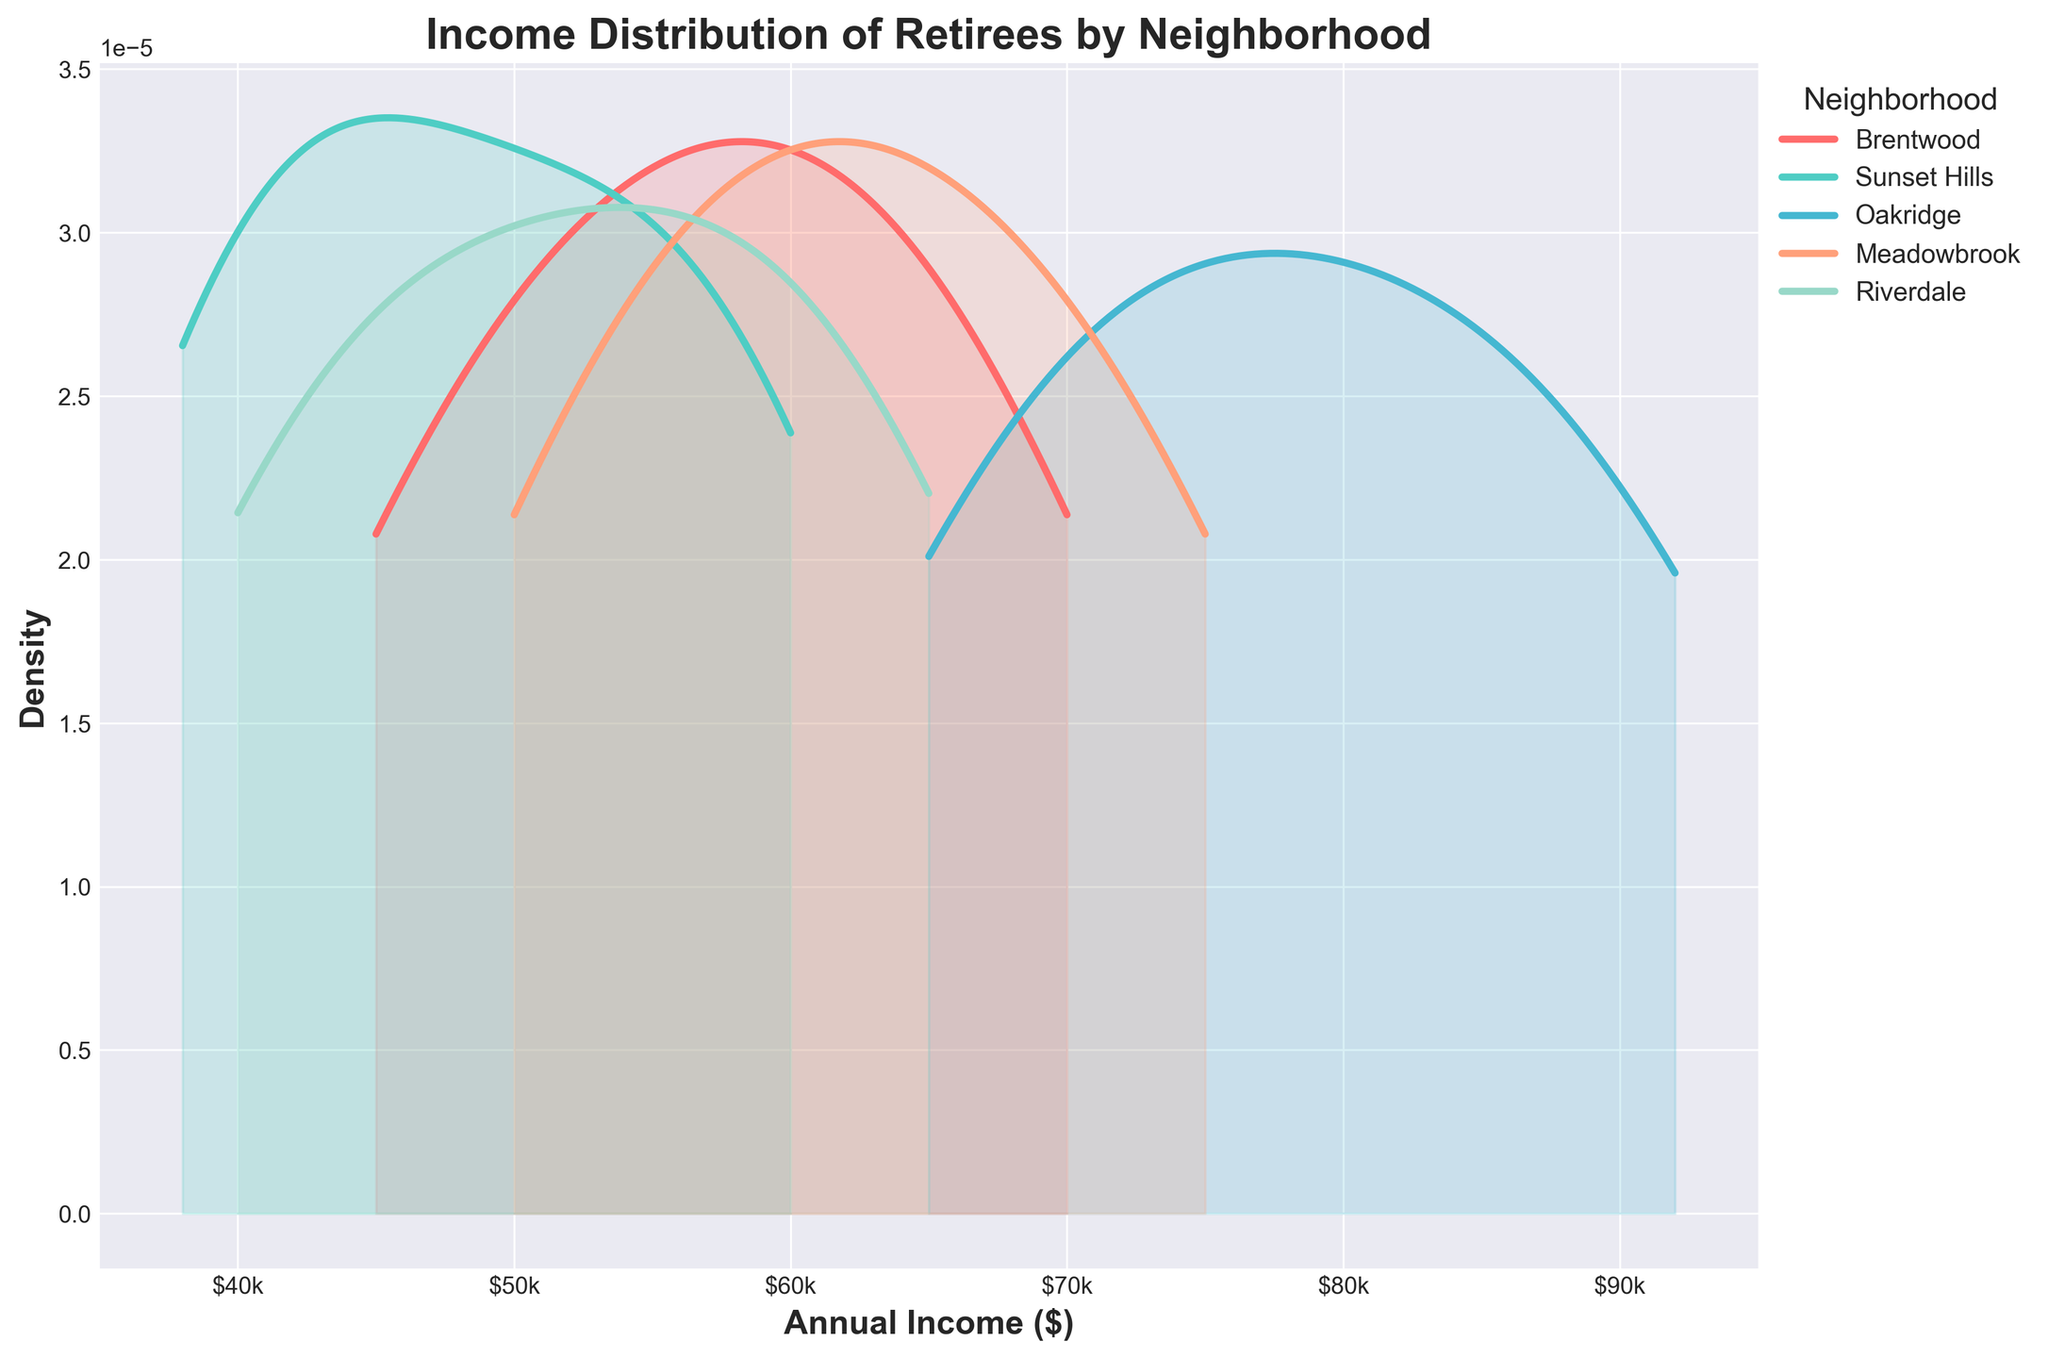What is the title of the plot? The title of the plot is usually displayed at the top. In this case, it clearly states the subject of the plot.
Answer: Income Distribution of Retirees by Neighborhood What does the x-axis represent? The x-axis label can be seen at the bottom of the plot, indicating what is being measured. Here it represents the annual income in dollars.
Answer: Annual Income Which neighborhood shows the highest density peak? By observing the density peaks of the different filled areas in the plot, the highest peak can be identified. The neighborhood with the highest peak has its highest density value.
Answer: Oakridge Which neighborhood has the widest income range? Looking at the spread of the density plots along the x-axis (annual income), the neighborhood that spans the widest range indicates the greatest income diversity.
Answer: Oakridge How do the income distributions of Brentwood and Sunset Hills compare? By visually comparing the density plots of Brentwood and Sunset Hills, one can assess if one has higher density peaks, wider spread, or overlaps at certain income levels. Brentwood appears more condensed with higher income while Sunset Hills is more spread out but at lower incomes.
Answer: Brentwood has higher incomes What is the range of annual incomes shown on the x-axis? The x-axis shows the minimum to maximum values being measured. Observing the limits of the plot indicates the income range covered in the plot.
Answer: $35,000 to $95,000 Which neighborhood has the least income variability? The neighborhood with the narrowest spread (least width) of its density plot along the x-axis, indicating that its incomes are clustered within a tighter range, has the least variability.
Answer: Riverdale Between the neighborhoods, which one has residents mostly earning between $55,000 and $65,000? By looking at the area within the $55,000 to $65,000 range on the x-axis and checking which neighborhood’s density plot has a significant portion of its area there, the answer can be found.
Answer: Riverdale Which neighborhoods have overlapping income distributions? By examining where the density plots of different neighborhoods intersect or closely align on the x-axis, one can identify neighborhoods with overlapping income distributions. Brentwood and Meadowbrook overlap significantly around the $55,000 to $68,000 range.
Answer: Brentwood and Meadowbrook 